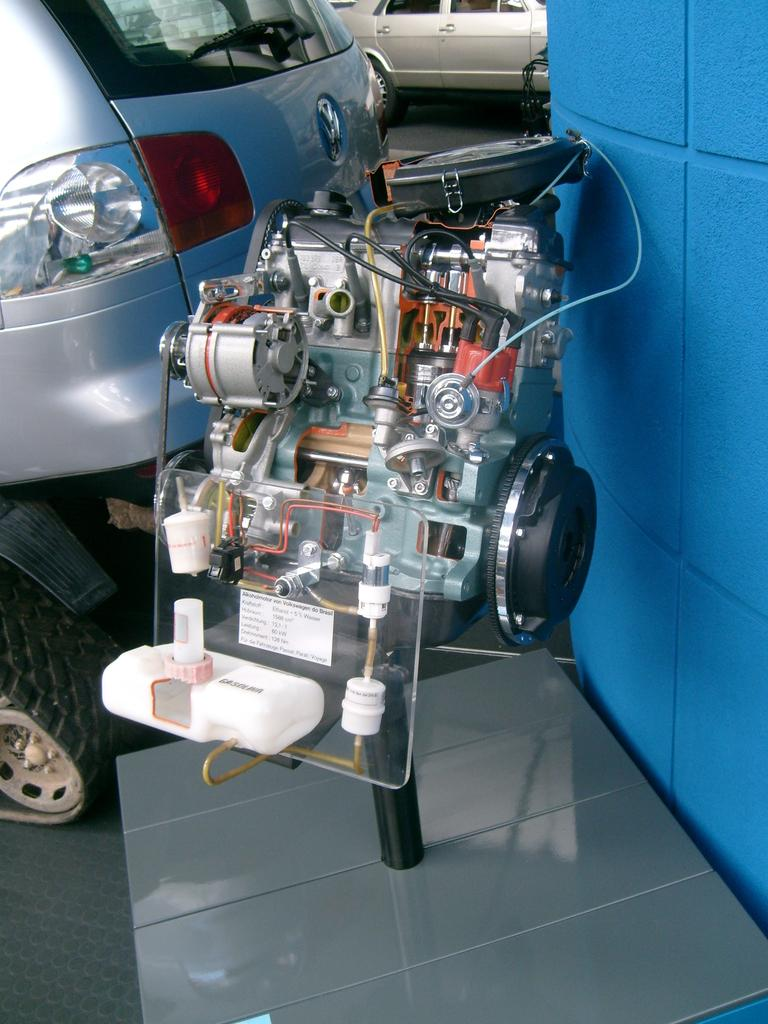What is the main subject in the foreground of the image? There is a machine in the foreground of the image. What else can be seen in the image besides the machine? There are vehicles visible in the image. What is located on the right side of the image? There is a wall on the right side of the image. How far away is the cellar from the machine in the image? There is no cellar present in the image, so it is not possible to determine the distance between it and the machine. 